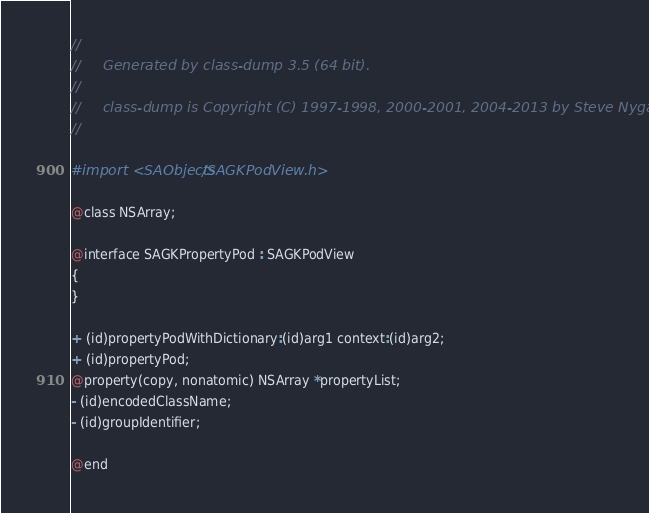<code> <loc_0><loc_0><loc_500><loc_500><_C_>//
//     Generated by class-dump 3.5 (64 bit).
//
//     class-dump is Copyright (C) 1997-1998, 2000-2001, 2004-2013 by Steve Nygard.
//

#import <SAObjects/SAGKPodView.h>

@class NSArray;

@interface SAGKPropertyPod : SAGKPodView
{
}

+ (id)propertyPodWithDictionary:(id)arg1 context:(id)arg2;
+ (id)propertyPod;
@property(copy, nonatomic) NSArray *propertyList;
- (id)encodedClassName;
- (id)groupIdentifier;

@end

</code> 